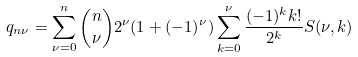Convert formula to latex. <formula><loc_0><loc_0><loc_500><loc_500>q _ { n \nu } = \sum _ { \nu = 0 } ^ { n } \binom { n } { \nu } 2 ^ { \nu } ( 1 + ( - 1 ) ^ { \nu } ) \sum _ { k = 0 } ^ { \nu } \frac { ( - 1 ) ^ { k } k ! } { 2 ^ { k } } S ( \nu , k )</formula> 